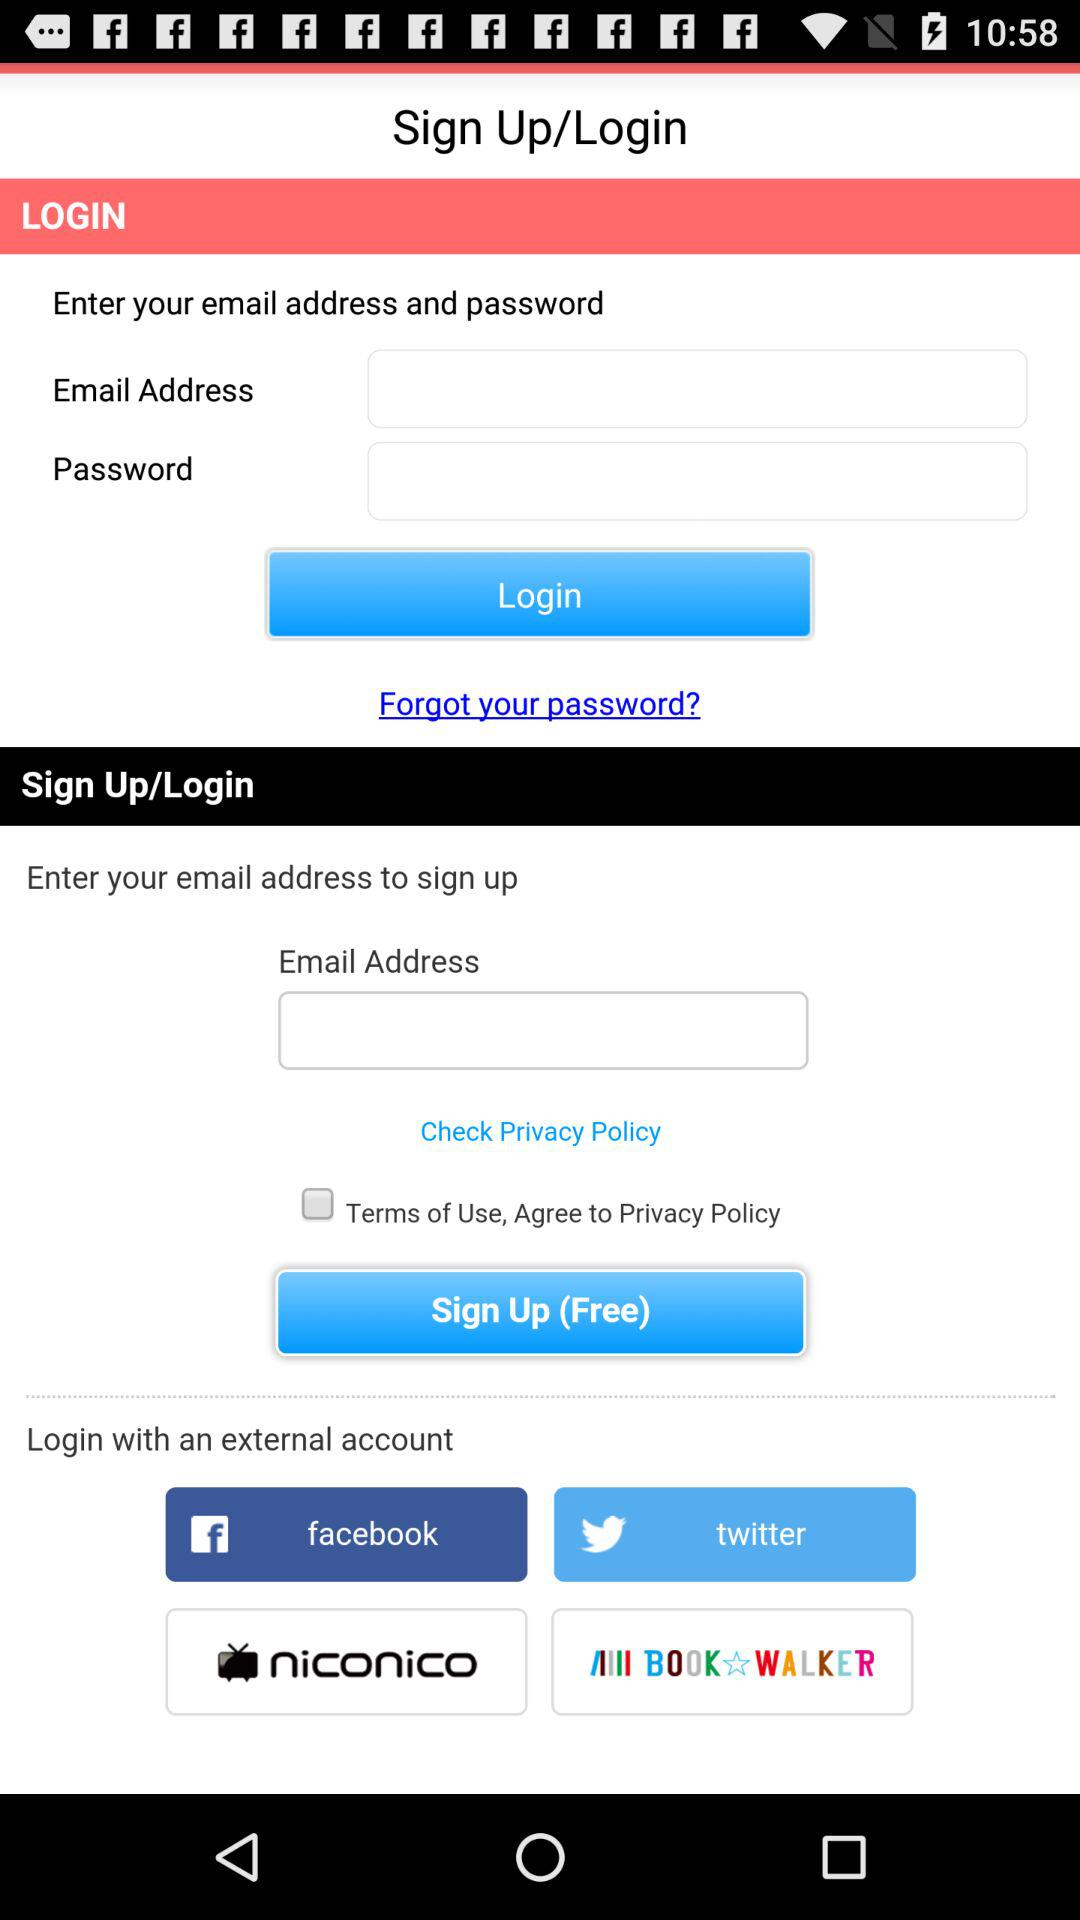What is the current status of the "Terms of Use, Agree to Privacy Policy"? The current status of the "Terms of Use, Agree to Privacy Policy" is "off". 